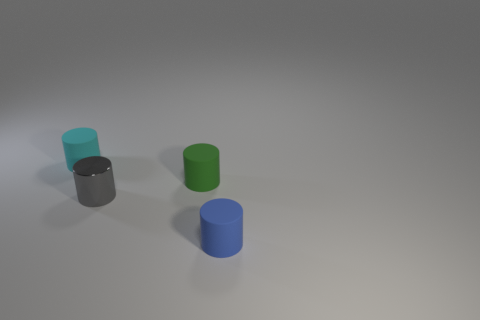How many brown spheres have the same material as the cyan thing? Upon reviewing the image, I can confirm that there are no brown spheres present at all. The visible objects are all cylinder-shaped, thus, there are zero brown spheres with the same material as the cyan-colored cylinder. 